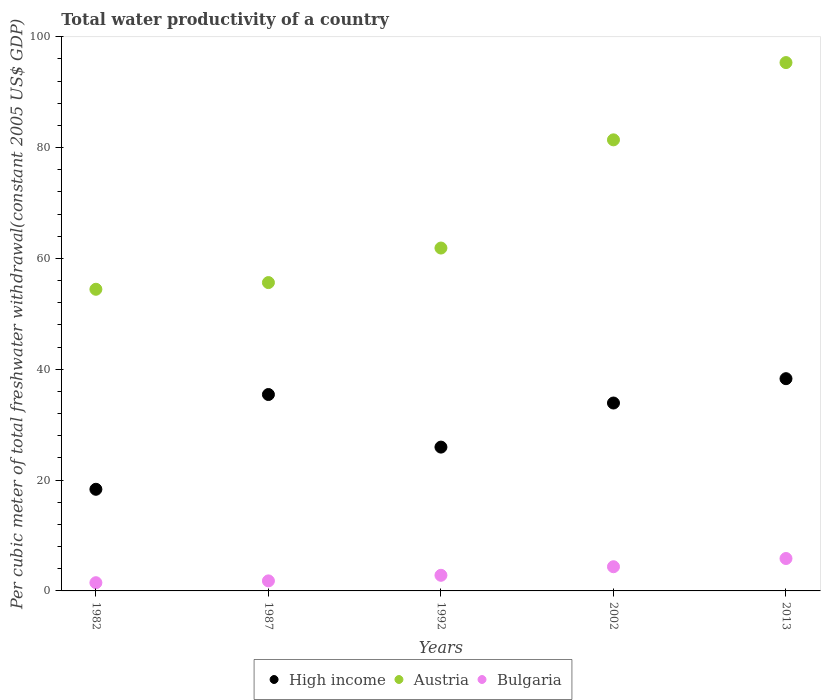What is the total water productivity in Bulgaria in 1992?
Make the answer very short. 2.82. Across all years, what is the maximum total water productivity in High income?
Keep it short and to the point. 38.3. Across all years, what is the minimum total water productivity in Austria?
Your response must be concise. 54.44. In which year was the total water productivity in Bulgaria maximum?
Your answer should be compact. 2013. What is the total total water productivity in Austria in the graph?
Make the answer very short. 348.71. What is the difference between the total water productivity in Austria in 1992 and that in 2002?
Keep it short and to the point. -19.52. What is the difference between the total water productivity in High income in 1992 and the total water productivity in Austria in 1987?
Your answer should be very brief. -29.69. What is the average total water productivity in High income per year?
Your answer should be compact. 30.39. In the year 1987, what is the difference between the total water productivity in Bulgaria and total water productivity in Austria?
Your response must be concise. -53.83. What is the ratio of the total water productivity in High income in 1982 to that in 2013?
Ensure brevity in your answer.  0.48. What is the difference between the highest and the second highest total water productivity in High income?
Make the answer very short. 2.86. What is the difference between the highest and the lowest total water productivity in High income?
Your response must be concise. 19.96. Does the total water productivity in Austria monotonically increase over the years?
Your answer should be very brief. Yes. Is the total water productivity in Bulgaria strictly greater than the total water productivity in High income over the years?
Provide a short and direct response. No. How many dotlines are there?
Your answer should be very brief. 3. Are the values on the major ticks of Y-axis written in scientific E-notation?
Ensure brevity in your answer.  No. Does the graph contain grids?
Give a very brief answer. No. Where does the legend appear in the graph?
Provide a short and direct response. Bottom center. How many legend labels are there?
Your response must be concise. 3. What is the title of the graph?
Provide a succinct answer. Total water productivity of a country. Does "Arab World" appear as one of the legend labels in the graph?
Make the answer very short. No. What is the label or title of the Y-axis?
Your answer should be very brief. Per cubic meter of total freshwater withdrawal(constant 2005 US$ GDP). What is the Per cubic meter of total freshwater withdrawal(constant 2005 US$ GDP) of High income in 1982?
Your response must be concise. 18.34. What is the Per cubic meter of total freshwater withdrawal(constant 2005 US$ GDP) in Austria in 1982?
Your answer should be very brief. 54.44. What is the Per cubic meter of total freshwater withdrawal(constant 2005 US$ GDP) of Bulgaria in 1982?
Keep it short and to the point. 1.48. What is the Per cubic meter of total freshwater withdrawal(constant 2005 US$ GDP) of High income in 1987?
Provide a succinct answer. 35.44. What is the Per cubic meter of total freshwater withdrawal(constant 2005 US$ GDP) of Austria in 1987?
Provide a succinct answer. 55.64. What is the Per cubic meter of total freshwater withdrawal(constant 2005 US$ GDP) of Bulgaria in 1987?
Make the answer very short. 1.81. What is the Per cubic meter of total freshwater withdrawal(constant 2005 US$ GDP) of High income in 1992?
Offer a terse response. 25.95. What is the Per cubic meter of total freshwater withdrawal(constant 2005 US$ GDP) of Austria in 1992?
Provide a short and direct response. 61.88. What is the Per cubic meter of total freshwater withdrawal(constant 2005 US$ GDP) of Bulgaria in 1992?
Offer a very short reply. 2.82. What is the Per cubic meter of total freshwater withdrawal(constant 2005 US$ GDP) of High income in 2002?
Offer a terse response. 33.91. What is the Per cubic meter of total freshwater withdrawal(constant 2005 US$ GDP) in Austria in 2002?
Give a very brief answer. 81.4. What is the Per cubic meter of total freshwater withdrawal(constant 2005 US$ GDP) of Bulgaria in 2002?
Provide a succinct answer. 4.37. What is the Per cubic meter of total freshwater withdrawal(constant 2005 US$ GDP) of High income in 2013?
Provide a short and direct response. 38.3. What is the Per cubic meter of total freshwater withdrawal(constant 2005 US$ GDP) in Austria in 2013?
Your answer should be compact. 95.35. What is the Per cubic meter of total freshwater withdrawal(constant 2005 US$ GDP) of Bulgaria in 2013?
Ensure brevity in your answer.  5.85. Across all years, what is the maximum Per cubic meter of total freshwater withdrawal(constant 2005 US$ GDP) of High income?
Offer a terse response. 38.3. Across all years, what is the maximum Per cubic meter of total freshwater withdrawal(constant 2005 US$ GDP) in Austria?
Provide a short and direct response. 95.35. Across all years, what is the maximum Per cubic meter of total freshwater withdrawal(constant 2005 US$ GDP) of Bulgaria?
Provide a short and direct response. 5.85. Across all years, what is the minimum Per cubic meter of total freshwater withdrawal(constant 2005 US$ GDP) in High income?
Your answer should be very brief. 18.34. Across all years, what is the minimum Per cubic meter of total freshwater withdrawal(constant 2005 US$ GDP) of Austria?
Make the answer very short. 54.44. Across all years, what is the minimum Per cubic meter of total freshwater withdrawal(constant 2005 US$ GDP) of Bulgaria?
Give a very brief answer. 1.48. What is the total Per cubic meter of total freshwater withdrawal(constant 2005 US$ GDP) of High income in the graph?
Provide a succinct answer. 151.95. What is the total Per cubic meter of total freshwater withdrawal(constant 2005 US$ GDP) of Austria in the graph?
Your answer should be very brief. 348.71. What is the total Per cubic meter of total freshwater withdrawal(constant 2005 US$ GDP) of Bulgaria in the graph?
Offer a very short reply. 16.33. What is the difference between the Per cubic meter of total freshwater withdrawal(constant 2005 US$ GDP) in High income in 1982 and that in 1987?
Provide a short and direct response. -17.1. What is the difference between the Per cubic meter of total freshwater withdrawal(constant 2005 US$ GDP) in Austria in 1982 and that in 1987?
Give a very brief answer. -1.21. What is the difference between the Per cubic meter of total freshwater withdrawal(constant 2005 US$ GDP) in Bulgaria in 1982 and that in 1987?
Provide a succinct answer. -0.33. What is the difference between the Per cubic meter of total freshwater withdrawal(constant 2005 US$ GDP) of High income in 1982 and that in 1992?
Keep it short and to the point. -7.61. What is the difference between the Per cubic meter of total freshwater withdrawal(constant 2005 US$ GDP) in Austria in 1982 and that in 1992?
Give a very brief answer. -7.44. What is the difference between the Per cubic meter of total freshwater withdrawal(constant 2005 US$ GDP) in Bulgaria in 1982 and that in 1992?
Your answer should be compact. -1.34. What is the difference between the Per cubic meter of total freshwater withdrawal(constant 2005 US$ GDP) in High income in 1982 and that in 2002?
Provide a short and direct response. -15.57. What is the difference between the Per cubic meter of total freshwater withdrawal(constant 2005 US$ GDP) in Austria in 1982 and that in 2002?
Make the answer very short. -26.97. What is the difference between the Per cubic meter of total freshwater withdrawal(constant 2005 US$ GDP) in Bulgaria in 1982 and that in 2002?
Keep it short and to the point. -2.88. What is the difference between the Per cubic meter of total freshwater withdrawal(constant 2005 US$ GDP) in High income in 1982 and that in 2013?
Your answer should be compact. -19.96. What is the difference between the Per cubic meter of total freshwater withdrawal(constant 2005 US$ GDP) in Austria in 1982 and that in 2013?
Ensure brevity in your answer.  -40.91. What is the difference between the Per cubic meter of total freshwater withdrawal(constant 2005 US$ GDP) in Bulgaria in 1982 and that in 2013?
Give a very brief answer. -4.37. What is the difference between the Per cubic meter of total freshwater withdrawal(constant 2005 US$ GDP) in High income in 1987 and that in 1992?
Ensure brevity in your answer.  9.49. What is the difference between the Per cubic meter of total freshwater withdrawal(constant 2005 US$ GDP) in Austria in 1987 and that in 1992?
Provide a succinct answer. -6.23. What is the difference between the Per cubic meter of total freshwater withdrawal(constant 2005 US$ GDP) in Bulgaria in 1987 and that in 1992?
Provide a succinct answer. -1.01. What is the difference between the Per cubic meter of total freshwater withdrawal(constant 2005 US$ GDP) in High income in 1987 and that in 2002?
Make the answer very short. 1.53. What is the difference between the Per cubic meter of total freshwater withdrawal(constant 2005 US$ GDP) of Austria in 1987 and that in 2002?
Your response must be concise. -25.76. What is the difference between the Per cubic meter of total freshwater withdrawal(constant 2005 US$ GDP) in Bulgaria in 1987 and that in 2002?
Keep it short and to the point. -2.55. What is the difference between the Per cubic meter of total freshwater withdrawal(constant 2005 US$ GDP) in High income in 1987 and that in 2013?
Your response must be concise. -2.86. What is the difference between the Per cubic meter of total freshwater withdrawal(constant 2005 US$ GDP) in Austria in 1987 and that in 2013?
Offer a very short reply. -39.7. What is the difference between the Per cubic meter of total freshwater withdrawal(constant 2005 US$ GDP) of Bulgaria in 1987 and that in 2013?
Your response must be concise. -4.04. What is the difference between the Per cubic meter of total freshwater withdrawal(constant 2005 US$ GDP) in High income in 1992 and that in 2002?
Offer a terse response. -7.96. What is the difference between the Per cubic meter of total freshwater withdrawal(constant 2005 US$ GDP) in Austria in 1992 and that in 2002?
Provide a short and direct response. -19.52. What is the difference between the Per cubic meter of total freshwater withdrawal(constant 2005 US$ GDP) in Bulgaria in 1992 and that in 2002?
Your answer should be very brief. -1.55. What is the difference between the Per cubic meter of total freshwater withdrawal(constant 2005 US$ GDP) in High income in 1992 and that in 2013?
Give a very brief answer. -12.35. What is the difference between the Per cubic meter of total freshwater withdrawal(constant 2005 US$ GDP) in Austria in 1992 and that in 2013?
Offer a terse response. -33.47. What is the difference between the Per cubic meter of total freshwater withdrawal(constant 2005 US$ GDP) of Bulgaria in 1992 and that in 2013?
Ensure brevity in your answer.  -3.03. What is the difference between the Per cubic meter of total freshwater withdrawal(constant 2005 US$ GDP) in High income in 2002 and that in 2013?
Provide a short and direct response. -4.39. What is the difference between the Per cubic meter of total freshwater withdrawal(constant 2005 US$ GDP) in Austria in 2002 and that in 2013?
Keep it short and to the point. -13.94. What is the difference between the Per cubic meter of total freshwater withdrawal(constant 2005 US$ GDP) of Bulgaria in 2002 and that in 2013?
Your answer should be very brief. -1.48. What is the difference between the Per cubic meter of total freshwater withdrawal(constant 2005 US$ GDP) of High income in 1982 and the Per cubic meter of total freshwater withdrawal(constant 2005 US$ GDP) of Austria in 1987?
Ensure brevity in your answer.  -37.3. What is the difference between the Per cubic meter of total freshwater withdrawal(constant 2005 US$ GDP) of High income in 1982 and the Per cubic meter of total freshwater withdrawal(constant 2005 US$ GDP) of Bulgaria in 1987?
Your answer should be compact. 16.53. What is the difference between the Per cubic meter of total freshwater withdrawal(constant 2005 US$ GDP) of Austria in 1982 and the Per cubic meter of total freshwater withdrawal(constant 2005 US$ GDP) of Bulgaria in 1987?
Keep it short and to the point. 52.63. What is the difference between the Per cubic meter of total freshwater withdrawal(constant 2005 US$ GDP) of High income in 1982 and the Per cubic meter of total freshwater withdrawal(constant 2005 US$ GDP) of Austria in 1992?
Provide a succinct answer. -43.54. What is the difference between the Per cubic meter of total freshwater withdrawal(constant 2005 US$ GDP) in High income in 1982 and the Per cubic meter of total freshwater withdrawal(constant 2005 US$ GDP) in Bulgaria in 1992?
Ensure brevity in your answer.  15.52. What is the difference between the Per cubic meter of total freshwater withdrawal(constant 2005 US$ GDP) of Austria in 1982 and the Per cubic meter of total freshwater withdrawal(constant 2005 US$ GDP) of Bulgaria in 1992?
Your answer should be compact. 51.62. What is the difference between the Per cubic meter of total freshwater withdrawal(constant 2005 US$ GDP) in High income in 1982 and the Per cubic meter of total freshwater withdrawal(constant 2005 US$ GDP) in Austria in 2002?
Your answer should be compact. -63.06. What is the difference between the Per cubic meter of total freshwater withdrawal(constant 2005 US$ GDP) of High income in 1982 and the Per cubic meter of total freshwater withdrawal(constant 2005 US$ GDP) of Bulgaria in 2002?
Provide a short and direct response. 13.98. What is the difference between the Per cubic meter of total freshwater withdrawal(constant 2005 US$ GDP) in Austria in 1982 and the Per cubic meter of total freshwater withdrawal(constant 2005 US$ GDP) in Bulgaria in 2002?
Your answer should be compact. 50.07. What is the difference between the Per cubic meter of total freshwater withdrawal(constant 2005 US$ GDP) of High income in 1982 and the Per cubic meter of total freshwater withdrawal(constant 2005 US$ GDP) of Austria in 2013?
Ensure brevity in your answer.  -77. What is the difference between the Per cubic meter of total freshwater withdrawal(constant 2005 US$ GDP) in High income in 1982 and the Per cubic meter of total freshwater withdrawal(constant 2005 US$ GDP) in Bulgaria in 2013?
Your response must be concise. 12.49. What is the difference between the Per cubic meter of total freshwater withdrawal(constant 2005 US$ GDP) in Austria in 1982 and the Per cubic meter of total freshwater withdrawal(constant 2005 US$ GDP) in Bulgaria in 2013?
Keep it short and to the point. 48.59. What is the difference between the Per cubic meter of total freshwater withdrawal(constant 2005 US$ GDP) of High income in 1987 and the Per cubic meter of total freshwater withdrawal(constant 2005 US$ GDP) of Austria in 1992?
Provide a succinct answer. -26.43. What is the difference between the Per cubic meter of total freshwater withdrawal(constant 2005 US$ GDP) in High income in 1987 and the Per cubic meter of total freshwater withdrawal(constant 2005 US$ GDP) in Bulgaria in 1992?
Your response must be concise. 32.62. What is the difference between the Per cubic meter of total freshwater withdrawal(constant 2005 US$ GDP) of Austria in 1987 and the Per cubic meter of total freshwater withdrawal(constant 2005 US$ GDP) of Bulgaria in 1992?
Offer a very short reply. 52.82. What is the difference between the Per cubic meter of total freshwater withdrawal(constant 2005 US$ GDP) in High income in 1987 and the Per cubic meter of total freshwater withdrawal(constant 2005 US$ GDP) in Austria in 2002?
Your answer should be very brief. -45.96. What is the difference between the Per cubic meter of total freshwater withdrawal(constant 2005 US$ GDP) of High income in 1987 and the Per cubic meter of total freshwater withdrawal(constant 2005 US$ GDP) of Bulgaria in 2002?
Give a very brief answer. 31.08. What is the difference between the Per cubic meter of total freshwater withdrawal(constant 2005 US$ GDP) of Austria in 1987 and the Per cubic meter of total freshwater withdrawal(constant 2005 US$ GDP) of Bulgaria in 2002?
Provide a short and direct response. 51.28. What is the difference between the Per cubic meter of total freshwater withdrawal(constant 2005 US$ GDP) in High income in 1987 and the Per cubic meter of total freshwater withdrawal(constant 2005 US$ GDP) in Austria in 2013?
Give a very brief answer. -59.9. What is the difference between the Per cubic meter of total freshwater withdrawal(constant 2005 US$ GDP) of High income in 1987 and the Per cubic meter of total freshwater withdrawal(constant 2005 US$ GDP) of Bulgaria in 2013?
Give a very brief answer. 29.59. What is the difference between the Per cubic meter of total freshwater withdrawal(constant 2005 US$ GDP) of Austria in 1987 and the Per cubic meter of total freshwater withdrawal(constant 2005 US$ GDP) of Bulgaria in 2013?
Provide a short and direct response. 49.8. What is the difference between the Per cubic meter of total freshwater withdrawal(constant 2005 US$ GDP) of High income in 1992 and the Per cubic meter of total freshwater withdrawal(constant 2005 US$ GDP) of Austria in 2002?
Give a very brief answer. -55.45. What is the difference between the Per cubic meter of total freshwater withdrawal(constant 2005 US$ GDP) in High income in 1992 and the Per cubic meter of total freshwater withdrawal(constant 2005 US$ GDP) in Bulgaria in 2002?
Offer a terse response. 21.59. What is the difference between the Per cubic meter of total freshwater withdrawal(constant 2005 US$ GDP) of Austria in 1992 and the Per cubic meter of total freshwater withdrawal(constant 2005 US$ GDP) of Bulgaria in 2002?
Offer a terse response. 57.51. What is the difference between the Per cubic meter of total freshwater withdrawal(constant 2005 US$ GDP) of High income in 1992 and the Per cubic meter of total freshwater withdrawal(constant 2005 US$ GDP) of Austria in 2013?
Offer a terse response. -69.39. What is the difference between the Per cubic meter of total freshwater withdrawal(constant 2005 US$ GDP) of High income in 1992 and the Per cubic meter of total freshwater withdrawal(constant 2005 US$ GDP) of Bulgaria in 2013?
Ensure brevity in your answer.  20.1. What is the difference between the Per cubic meter of total freshwater withdrawal(constant 2005 US$ GDP) in Austria in 1992 and the Per cubic meter of total freshwater withdrawal(constant 2005 US$ GDP) in Bulgaria in 2013?
Provide a succinct answer. 56.03. What is the difference between the Per cubic meter of total freshwater withdrawal(constant 2005 US$ GDP) of High income in 2002 and the Per cubic meter of total freshwater withdrawal(constant 2005 US$ GDP) of Austria in 2013?
Your answer should be compact. -61.44. What is the difference between the Per cubic meter of total freshwater withdrawal(constant 2005 US$ GDP) in High income in 2002 and the Per cubic meter of total freshwater withdrawal(constant 2005 US$ GDP) in Bulgaria in 2013?
Your answer should be very brief. 28.06. What is the difference between the Per cubic meter of total freshwater withdrawal(constant 2005 US$ GDP) in Austria in 2002 and the Per cubic meter of total freshwater withdrawal(constant 2005 US$ GDP) in Bulgaria in 2013?
Make the answer very short. 75.55. What is the average Per cubic meter of total freshwater withdrawal(constant 2005 US$ GDP) of High income per year?
Keep it short and to the point. 30.39. What is the average Per cubic meter of total freshwater withdrawal(constant 2005 US$ GDP) of Austria per year?
Your response must be concise. 69.74. What is the average Per cubic meter of total freshwater withdrawal(constant 2005 US$ GDP) in Bulgaria per year?
Keep it short and to the point. 3.27. In the year 1982, what is the difference between the Per cubic meter of total freshwater withdrawal(constant 2005 US$ GDP) in High income and Per cubic meter of total freshwater withdrawal(constant 2005 US$ GDP) in Austria?
Provide a short and direct response. -36.1. In the year 1982, what is the difference between the Per cubic meter of total freshwater withdrawal(constant 2005 US$ GDP) of High income and Per cubic meter of total freshwater withdrawal(constant 2005 US$ GDP) of Bulgaria?
Give a very brief answer. 16.86. In the year 1982, what is the difference between the Per cubic meter of total freshwater withdrawal(constant 2005 US$ GDP) of Austria and Per cubic meter of total freshwater withdrawal(constant 2005 US$ GDP) of Bulgaria?
Offer a terse response. 52.95. In the year 1987, what is the difference between the Per cubic meter of total freshwater withdrawal(constant 2005 US$ GDP) in High income and Per cubic meter of total freshwater withdrawal(constant 2005 US$ GDP) in Austria?
Provide a short and direct response. -20.2. In the year 1987, what is the difference between the Per cubic meter of total freshwater withdrawal(constant 2005 US$ GDP) in High income and Per cubic meter of total freshwater withdrawal(constant 2005 US$ GDP) in Bulgaria?
Your response must be concise. 33.63. In the year 1987, what is the difference between the Per cubic meter of total freshwater withdrawal(constant 2005 US$ GDP) of Austria and Per cubic meter of total freshwater withdrawal(constant 2005 US$ GDP) of Bulgaria?
Provide a short and direct response. 53.83. In the year 1992, what is the difference between the Per cubic meter of total freshwater withdrawal(constant 2005 US$ GDP) in High income and Per cubic meter of total freshwater withdrawal(constant 2005 US$ GDP) in Austria?
Keep it short and to the point. -35.92. In the year 1992, what is the difference between the Per cubic meter of total freshwater withdrawal(constant 2005 US$ GDP) in High income and Per cubic meter of total freshwater withdrawal(constant 2005 US$ GDP) in Bulgaria?
Make the answer very short. 23.13. In the year 1992, what is the difference between the Per cubic meter of total freshwater withdrawal(constant 2005 US$ GDP) in Austria and Per cubic meter of total freshwater withdrawal(constant 2005 US$ GDP) in Bulgaria?
Your answer should be compact. 59.06. In the year 2002, what is the difference between the Per cubic meter of total freshwater withdrawal(constant 2005 US$ GDP) of High income and Per cubic meter of total freshwater withdrawal(constant 2005 US$ GDP) of Austria?
Make the answer very short. -47.49. In the year 2002, what is the difference between the Per cubic meter of total freshwater withdrawal(constant 2005 US$ GDP) in High income and Per cubic meter of total freshwater withdrawal(constant 2005 US$ GDP) in Bulgaria?
Your response must be concise. 29.54. In the year 2002, what is the difference between the Per cubic meter of total freshwater withdrawal(constant 2005 US$ GDP) of Austria and Per cubic meter of total freshwater withdrawal(constant 2005 US$ GDP) of Bulgaria?
Offer a very short reply. 77.04. In the year 2013, what is the difference between the Per cubic meter of total freshwater withdrawal(constant 2005 US$ GDP) of High income and Per cubic meter of total freshwater withdrawal(constant 2005 US$ GDP) of Austria?
Give a very brief answer. -57.04. In the year 2013, what is the difference between the Per cubic meter of total freshwater withdrawal(constant 2005 US$ GDP) of High income and Per cubic meter of total freshwater withdrawal(constant 2005 US$ GDP) of Bulgaria?
Your answer should be compact. 32.45. In the year 2013, what is the difference between the Per cubic meter of total freshwater withdrawal(constant 2005 US$ GDP) of Austria and Per cubic meter of total freshwater withdrawal(constant 2005 US$ GDP) of Bulgaria?
Ensure brevity in your answer.  89.5. What is the ratio of the Per cubic meter of total freshwater withdrawal(constant 2005 US$ GDP) in High income in 1982 to that in 1987?
Provide a short and direct response. 0.52. What is the ratio of the Per cubic meter of total freshwater withdrawal(constant 2005 US$ GDP) of Austria in 1982 to that in 1987?
Ensure brevity in your answer.  0.98. What is the ratio of the Per cubic meter of total freshwater withdrawal(constant 2005 US$ GDP) in Bulgaria in 1982 to that in 1987?
Your response must be concise. 0.82. What is the ratio of the Per cubic meter of total freshwater withdrawal(constant 2005 US$ GDP) in High income in 1982 to that in 1992?
Your answer should be very brief. 0.71. What is the ratio of the Per cubic meter of total freshwater withdrawal(constant 2005 US$ GDP) of Austria in 1982 to that in 1992?
Your response must be concise. 0.88. What is the ratio of the Per cubic meter of total freshwater withdrawal(constant 2005 US$ GDP) of Bulgaria in 1982 to that in 1992?
Your answer should be very brief. 0.53. What is the ratio of the Per cubic meter of total freshwater withdrawal(constant 2005 US$ GDP) in High income in 1982 to that in 2002?
Your answer should be very brief. 0.54. What is the ratio of the Per cubic meter of total freshwater withdrawal(constant 2005 US$ GDP) in Austria in 1982 to that in 2002?
Provide a succinct answer. 0.67. What is the ratio of the Per cubic meter of total freshwater withdrawal(constant 2005 US$ GDP) in Bulgaria in 1982 to that in 2002?
Ensure brevity in your answer.  0.34. What is the ratio of the Per cubic meter of total freshwater withdrawal(constant 2005 US$ GDP) in High income in 1982 to that in 2013?
Ensure brevity in your answer.  0.48. What is the ratio of the Per cubic meter of total freshwater withdrawal(constant 2005 US$ GDP) in Austria in 1982 to that in 2013?
Give a very brief answer. 0.57. What is the ratio of the Per cubic meter of total freshwater withdrawal(constant 2005 US$ GDP) in Bulgaria in 1982 to that in 2013?
Your answer should be very brief. 0.25. What is the ratio of the Per cubic meter of total freshwater withdrawal(constant 2005 US$ GDP) of High income in 1987 to that in 1992?
Make the answer very short. 1.37. What is the ratio of the Per cubic meter of total freshwater withdrawal(constant 2005 US$ GDP) of Austria in 1987 to that in 1992?
Your answer should be very brief. 0.9. What is the ratio of the Per cubic meter of total freshwater withdrawal(constant 2005 US$ GDP) in Bulgaria in 1987 to that in 1992?
Provide a succinct answer. 0.64. What is the ratio of the Per cubic meter of total freshwater withdrawal(constant 2005 US$ GDP) of High income in 1987 to that in 2002?
Offer a terse response. 1.05. What is the ratio of the Per cubic meter of total freshwater withdrawal(constant 2005 US$ GDP) in Austria in 1987 to that in 2002?
Ensure brevity in your answer.  0.68. What is the ratio of the Per cubic meter of total freshwater withdrawal(constant 2005 US$ GDP) in Bulgaria in 1987 to that in 2002?
Keep it short and to the point. 0.41. What is the ratio of the Per cubic meter of total freshwater withdrawal(constant 2005 US$ GDP) in High income in 1987 to that in 2013?
Ensure brevity in your answer.  0.93. What is the ratio of the Per cubic meter of total freshwater withdrawal(constant 2005 US$ GDP) in Austria in 1987 to that in 2013?
Ensure brevity in your answer.  0.58. What is the ratio of the Per cubic meter of total freshwater withdrawal(constant 2005 US$ GDP) of Bulgaria in 1987 to that in 2013?
Offer a very short reply. 0.31. What is the ratio of the Per cubic meter of total freshwater withdrawal(constant 2005 US$ GDP) in High income in 1992 to that in 2002?
Make the answer very short. 0.77. What is the ratio of the Per cubic meter of total freshwater withdrawal(constant 2005 US$ GDP) in Austria in 1992 to that in 2002?
Make the answer very short. 0.76. What is the ratio of the Per cubic meter of total freshwater withdrawal(constant 2005 US$ GDP) of Bulgaria in 1992 to that in 2002?
Your response must be concise. 0.65. What is the ratio of the Per cubic meter of total freshwater withdrawal(constant 2005 US$ GDP) in High income in 1992 to that in 2013?
Make the answer very short. 0.68. What is the ratio of the Per cubic meter of total freshwater withdrawal(constant 2005 US$ GDP) of Austria in 1992 to that in 2013?
Provide a short and direct response. 0.65. What is the ratio of the Per cubic meter of total freshwater withdrawal(constant 2005 US$ GDP) in Bulgaria in 1992 to that in 2013?
Your response must be concise. 0.48. What is the ratio of the Per cubic meter of total freshwater withdrawal(constant 2005 US$ GDP) in High income in 2002 to that in 2013?
Offer a terse response. 0.89. What is the ratio of the Per cubic meter of total freshwater withdrawal(constant 2005 US$ GDP) in Austria in 2002 to that in 2013?
Ensure brevity in your answer.  0.85. What is the ratio of the Per cubic meter of total freshwater withdrawal(constant 2005 US$ GDP) in Bulgaria in 2002 to that in 2013?
Your response must be concise. 0.75. What is the difference between the highest and the second highest Per cubic meter of total freshwater withdrawal(constant 2005 US$ GDP) in High income?
Provide a succinct answer. 2.86. What is the difference between the highest and the second highest Per cubic meter of total freshwater withdrawal(constant 2005 US$ GDP) of Austria?
Your response must be concise. 13.94. What is the difference between the highest and the second highest Per cubic meter of total freshwater withdrawal(constant 2005 US$ GDP) in Bulgaria?
Provide a succinct answer. 1.48. What is the difference between the highest and the lowest Per cubic meter of total freshwater withdrawal(constant 2005 US$ GDP) of High income?
Offer a very short reply. 19.96. What is the difference between the highest and the lowest Per cubic meter of total freshwater withdrawal(constant 2005 US$ GDP) of Austria?
Provide a short and direct response. 40.91. What is the difference between the highest and the lowest Per cubic meter of total freshwater withdrawal(constant 2005 US$ GDP) of Bulgaria?
Offer a terse response. 4.37. 